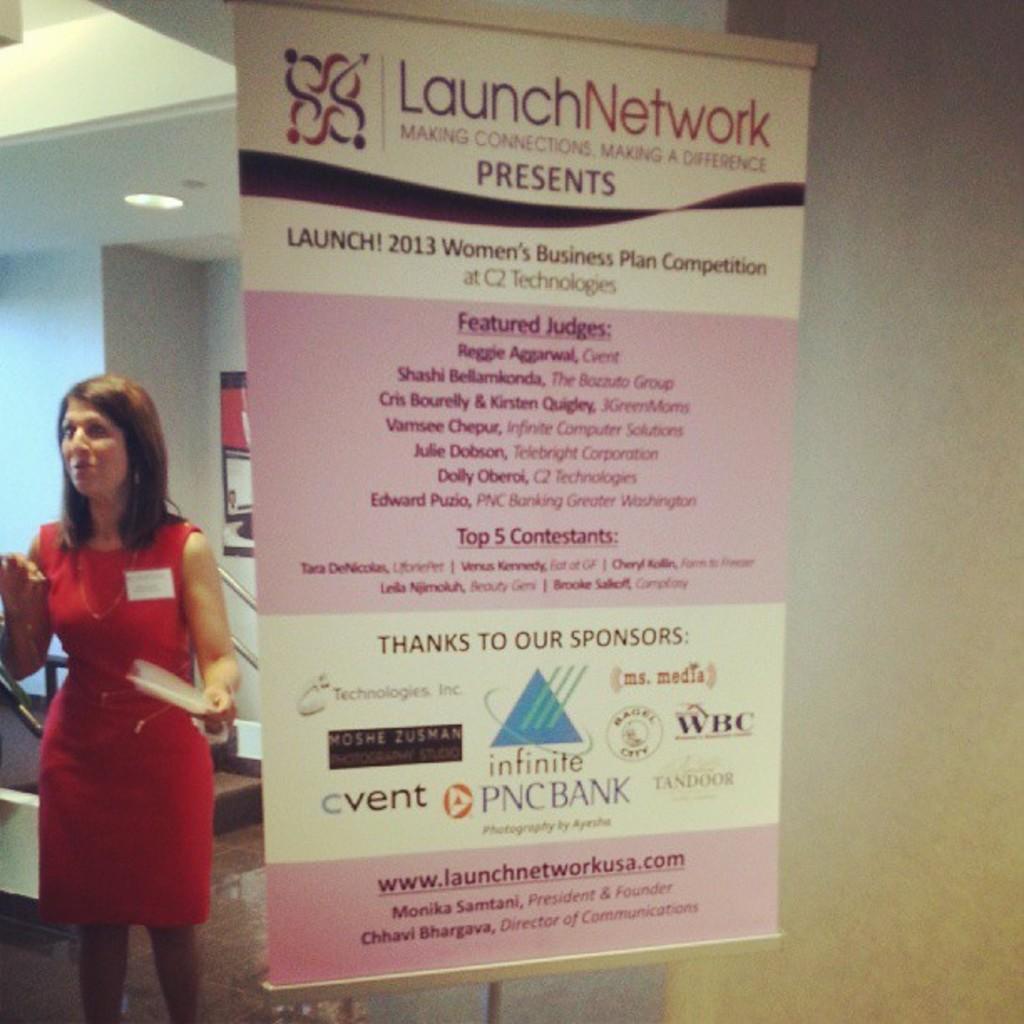Please provide a concise description of this image. In this image we can see a poster with some text and logos on it, behind it there is a lady standing and holding a paper, in the background there are some objects. 